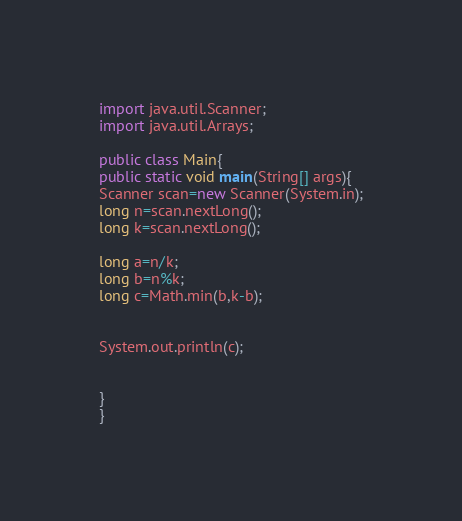Convert code to text. <code><loc_0><loc_0><loc_500><loc_500><_Java_>import java.util.Scanner;
import java.util.Arrays;

public class Main{
public static void main(String[] args){
Scanner scan=new Scanner(System.in);
long n=scan.nextLong();
long k=scan.nextLong();

long a=n/k;
long b=n%k;
long c=Math.min(b,k-b);


System.out.println(c);


}
}
</code> 